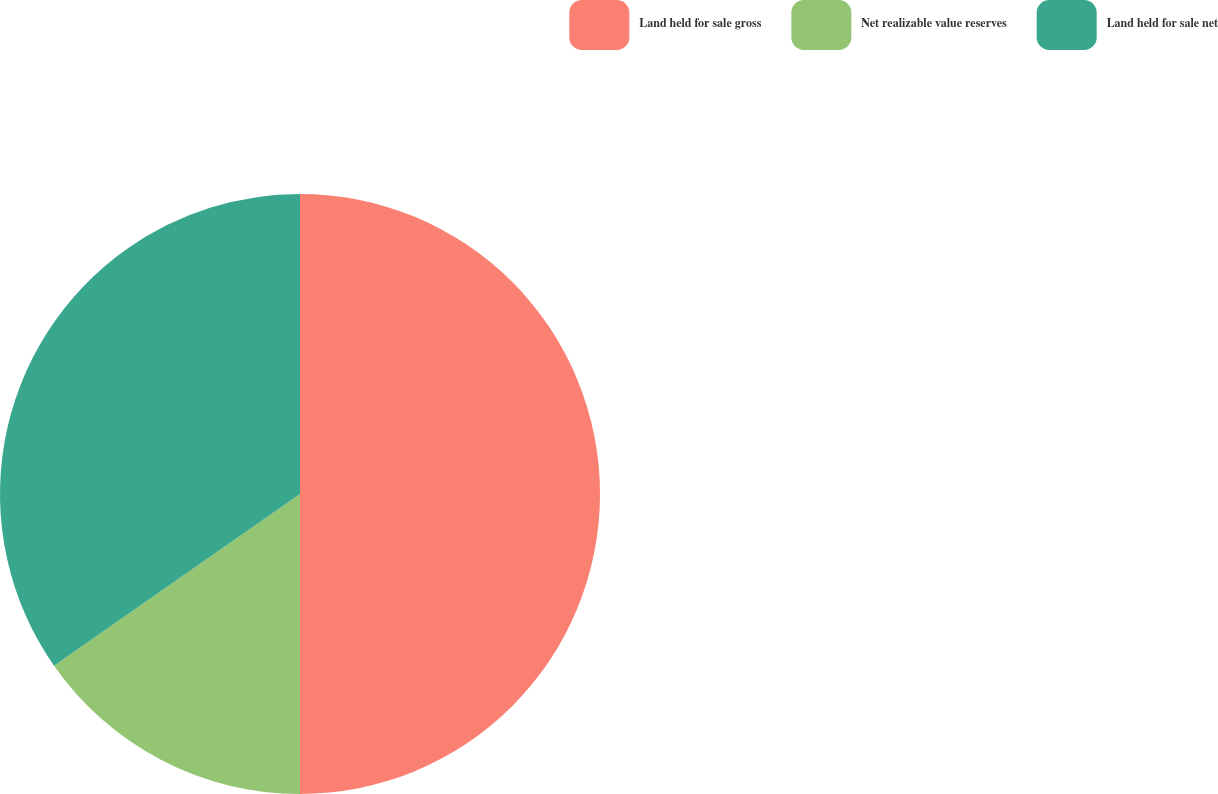Convert chart to OTSL. <chart><loc_0><loc_0><loc_500><loc_500><pie_chart><fcel>Land held for sale gross<fcel>Net realizable value reserves<fcel>Land held for sale net<nl><fcel>50.0%<fcel>15.3%<fcel>34.7%<nl></chart> 